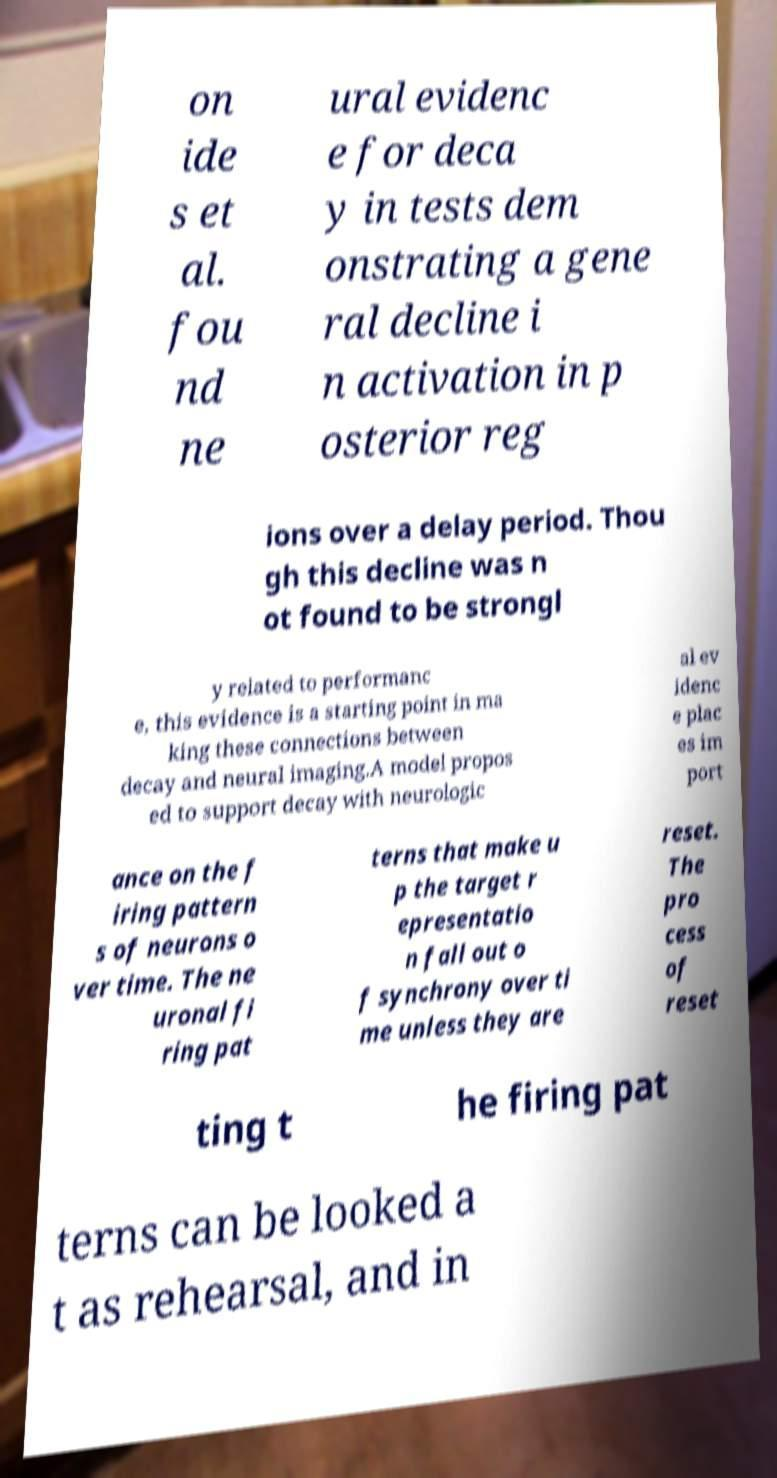Can you accurately transcribe the text from the provided image for me? on ide s et al. fou nd ne ural evidenc e for deca y in tests dem onstrating a gene ral decline i n activation in p osterior reg ions over a delay period. Thou gh this decline was n ot found to be strongl y related to performanc e, this evidence is a starting point in ma king these connections between decay and neural imaging.A model propos ed to support decay with neurologic al ev idenc e plac es im port ance on the f iring pattern s of neurons o ver time. The ne uronal fi ring pat terns that make u p the target r epresentatio n fall out o f synchrony over ti me unless they are reset. The pro cess of reset ting t he firing pat terns can be looked a t as rehearsal, and in 